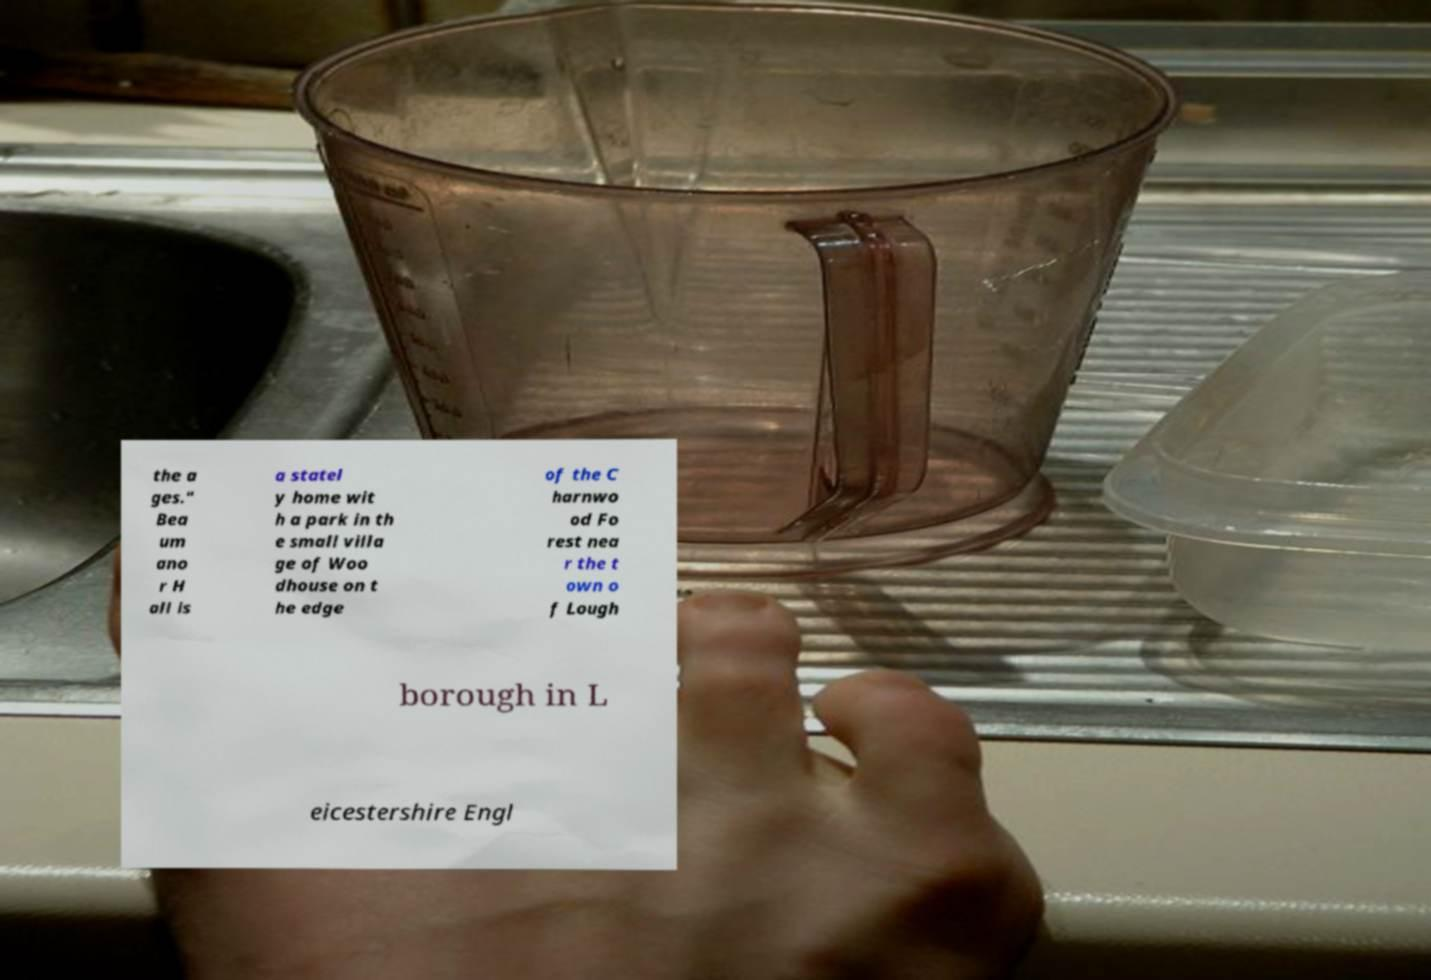Can you read and provide the text displayed in the image?This photo seems to have some interesting text. Can you extract and type it out for me? the a ges." Bea um ano r H all is a statel y home wit h a park in th e small villa ge of Woo dhouse on t he edge of the C harnwo od Fo rest nea r the t own o f Lough borough in L eicestershire Engl 